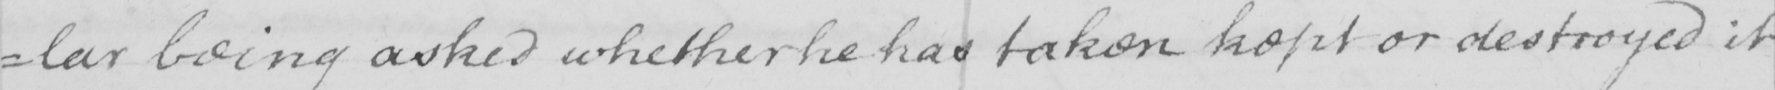Transcribe the text shown in this historical manuscript line. =lar being asked whether he has taken kept or destroyed it 